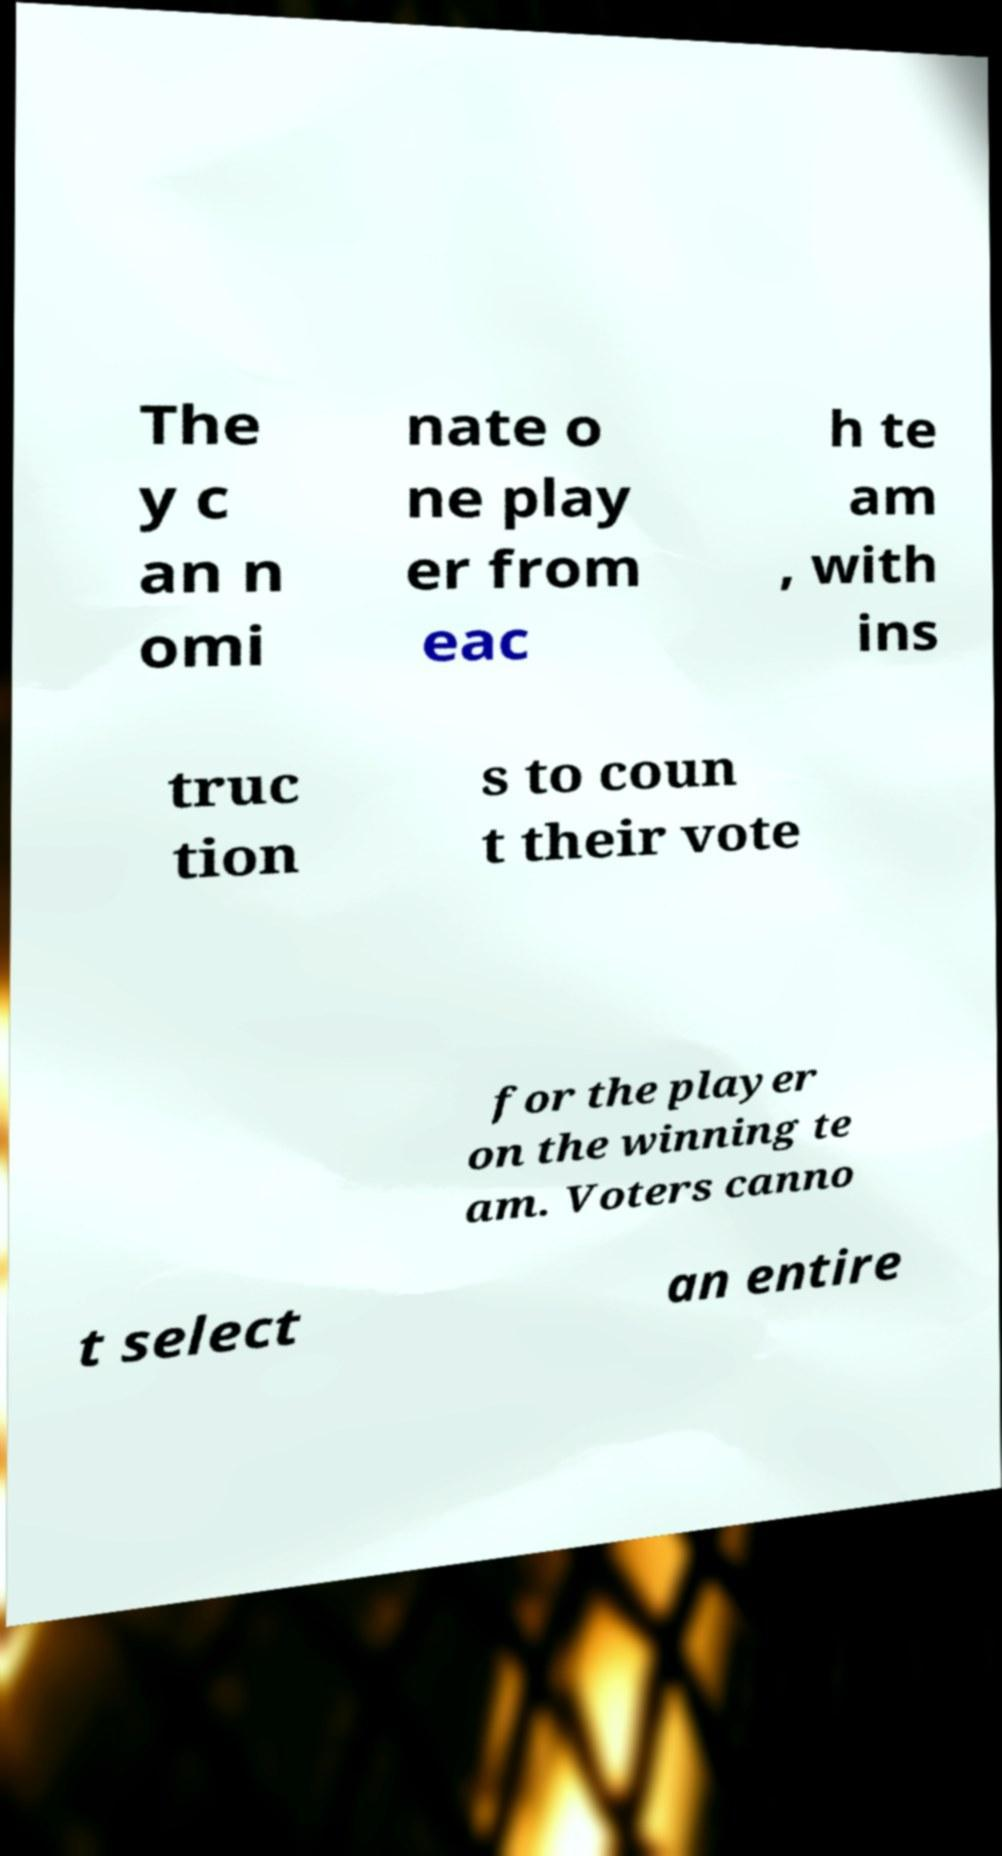What messages or text are displayed in this image? I need them in a readable, typed format. The y c an n omi nate o ne play er from eac h te am , with ins truc tion s to coun t their vote for the player on the winning te am. Voters canno t select an entire 